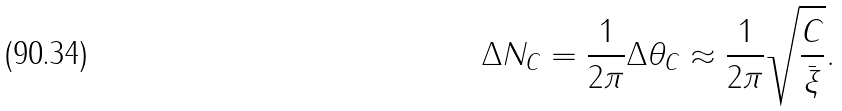Convert formula to latex. <formula><loc_0><loc_0><loc_500><loc_500>\Delta N _ { C } = \frac { 1 } { 2 \pi } \Delta \theta _ { C } \approx \frac { 1 } { 2 \pi } \sqrt { \frac { C } { \bar { \xi } } } .</formula> 